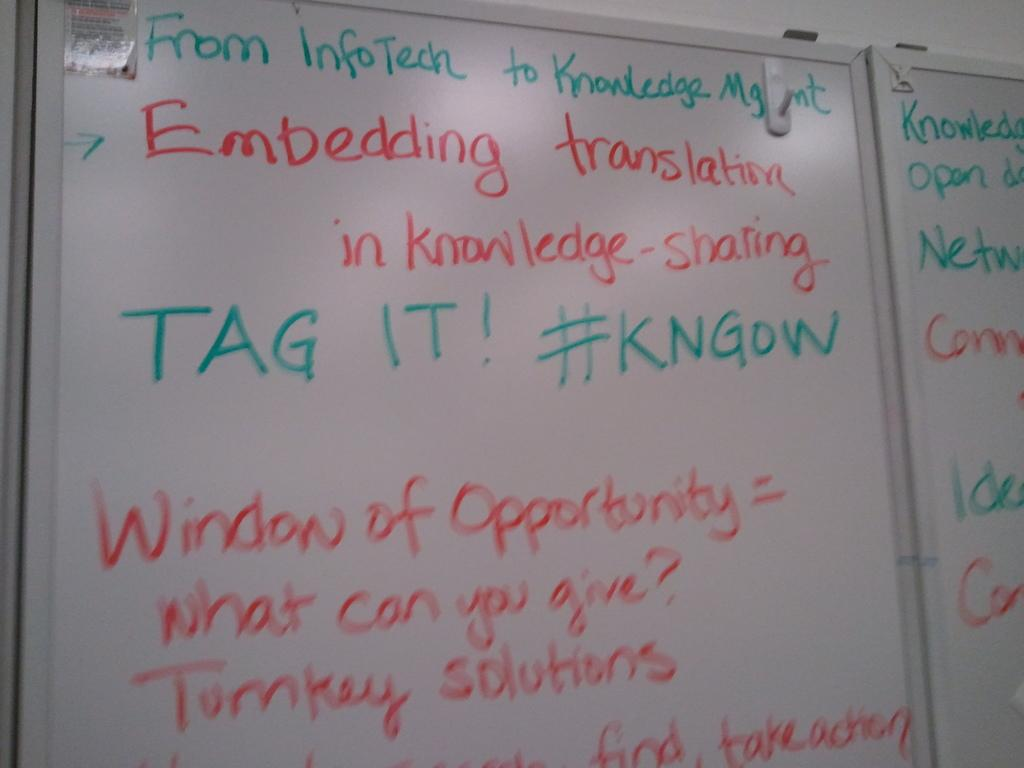<image>
Write a terse but informative summary of the picture. A white board explains the window of opportunity and says "what can you give?" 